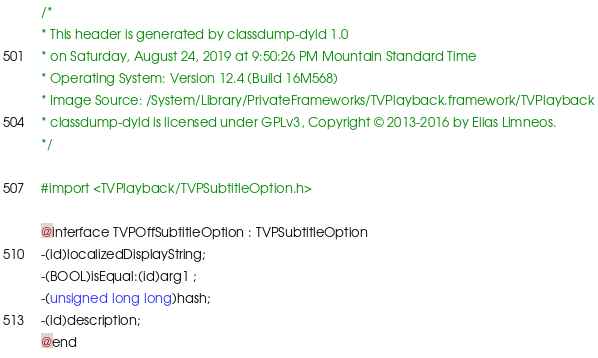Convert code to text. <code><loc_0><loc_0><loc_500><loc_500><_C_>/*
* This header is generated by classdump-dyld 1.0
* on Saturday, August 24, 2019 at 9:50:26 PM Mountain Standard Time
* Operating System: Version 12.4 (Build 16M568)
* Image Source: /System/Library/PrivateFrameworks/TVPlayback.framework/TVPlayback
* classdump-dyld is licensed under GPLv3, Copyright © 2013-2016 by Elias Limneos.
*/

#import <TVPlayback/TVPSubtitleOption.h>

@interface TVPOffSubtitleOption : TVPSubtitleOption
-(id)localizedDisplayString;
-(BOOL)isEqual:(id)arg1 ;
-(unsigned long long)hash;
-(id)description;
@end

</code> 